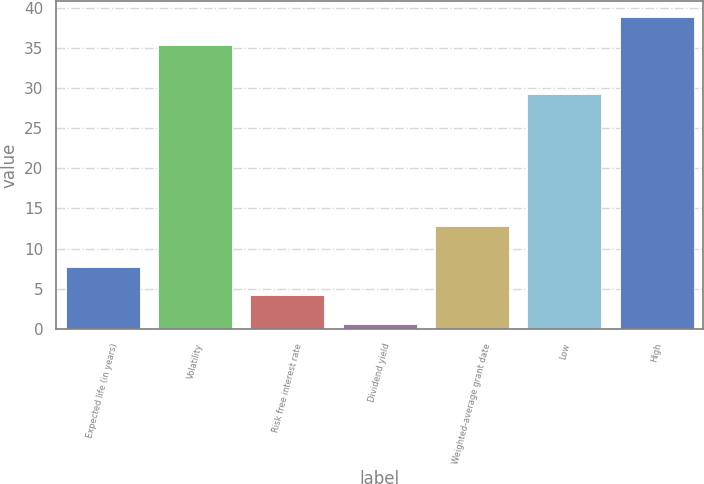Convert chart. <chart><loc_0><loc_0><loc_500><loc_500><bar_chart><fcel>Expected life (in years)<fcel>Volatility<fcel>Risk free interest rate<fcel>Dividend yield<fcel>Weighted-average grant date<fcel>Low<fcel>High<nl><fcel>7.73<fcel>35.31<fcel>4.2<fcel>0.67<fcel>12.83<fcel>29.2<fcel>38.84<nl></chart> 